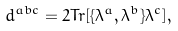Convert formula to latex. <formula><loc_0><loc_0><loc_500><loc_500>d ^ { a b c } = 2 T r [ \{ \lambda ^ { a } , \lambda ^ { b } \} \lambda ^ { c } ] ,</formula> 